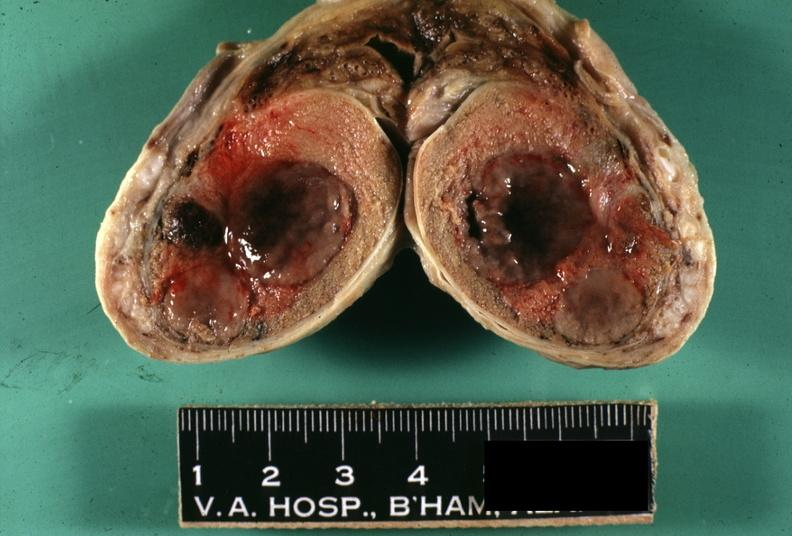what does this image show?
Answer the question using a single word or phrase. Fixed tissue tumor masses with necrosis easily seen 